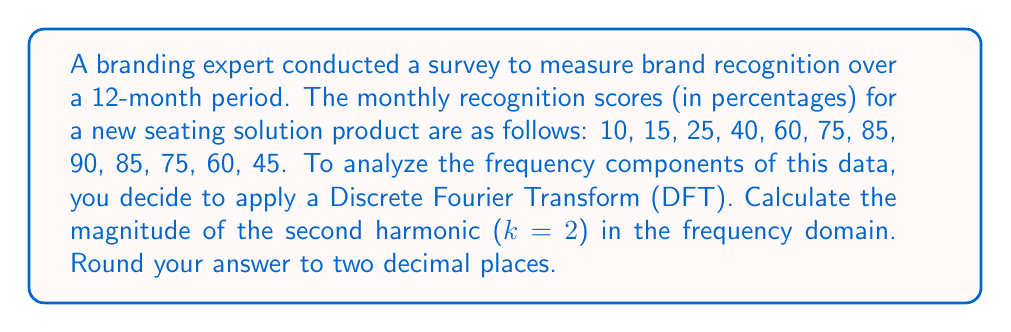Can you solve this math problem? To solve this problem, we'll follow these steps:

1) First, recall the formula for the Discrete Fourier Transform:

   $$X_k = \sum_{n=0}^{N-1} x_n e^{-i2\pi kn/N}$$

   where $X_k$ is the k-th frequency component, $x_n$ are the time-domain samples, N is the total number of samples, and k is the frequency index.

2) In our case, N = 12 (12 months of data), and we're interested in k = 2 (the second harmonic).

3) Let's substitute these values into the formula:

   $$X_2 = \sum_{n=0}^{11} x_n e^{-i2\pi (2)n/12}$$

4) Now, we'll calculate this sum using Euler's formula, $e^{-ix} = \cos(x) - i\sin(x)$:

   $$X_2 = \sum_{n=0}^{11} x_n [\cos(-\frac{\pi n}{3}) - i\sin(-\frac{\pi n}{3})]$$

5) Let's calculate this sum term by term:

   n=0:  10 * (1 - 0i) = 10
   n=1:  15 * (0.5 + 0.866i) = 7.5 + 12.99i
   n=2:  25 * (-0.5 + 0.866i) = -12.5 + 21.65i
   n=3:  40 * (-1 + 0i) = -40
   n=4:  60 * (-0.5 - 0.866i) = -30 - 51.96i
   n=5:  75 * (0.5 - 0.866i) = 37.5 - 64.95i
   n=6:  85 * (1 + 0i) = 85
   n=7:  90 * (0.5 + 0.866i) = 45 + 77.94i
   n=8:  85 * (-0.5 + 0.866i) = -42.5 + 73.61i
   n=9:  75 * (-1 + 0i) = -75
   n=10: 60 * (-0.5 - 0.866i) = -30 - 51.96i
   n=11: 45 * (0.5 - 0.866i) = 22.5 - 38.97i

6) Sum all these terms:

   $$X_2 = -22.5 - 21.65i$$

7) To find the magnitude, we use the formula $|X_2| = \sqrt{Re(X_2)^2 + Im(X_2)^2}$:

   $$|X_2| = \sqrt{(-22.5)^2 + (-21.65)^2} = 31.24$$

8) Rounding to two decimal places, we get 31.24.
Answer: 31.24 